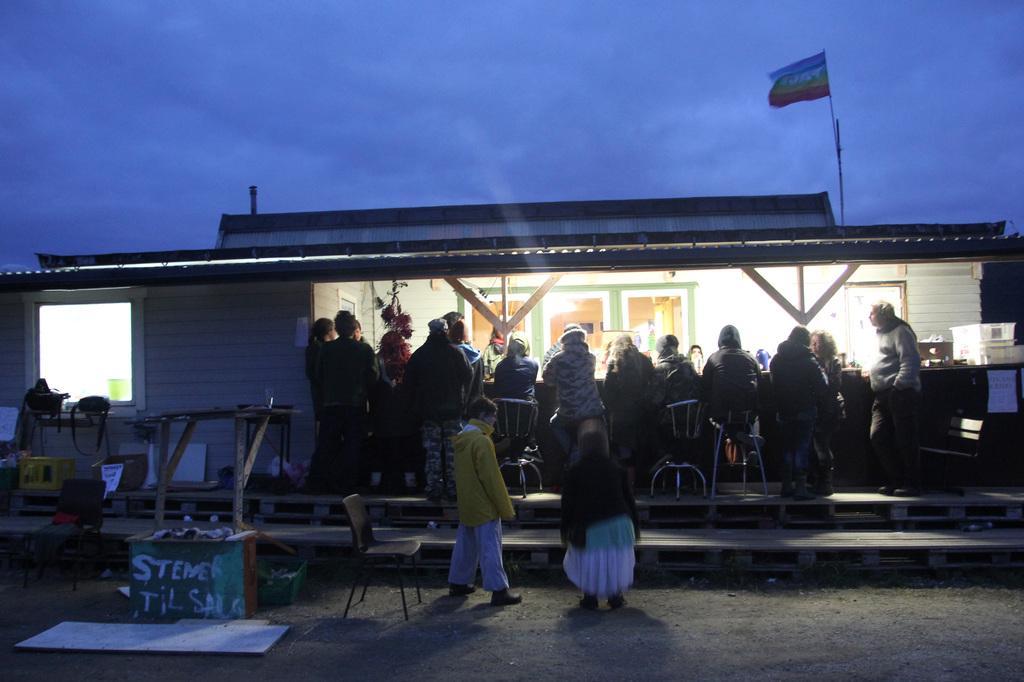Describe this image in one or two sentences. In this image we can see the people standing near the shed. And there are windows and flag. In front of the shed there are chairs, boxes, boards, bags, wooden sticks and a few objects. In the background, we can see the sky. 